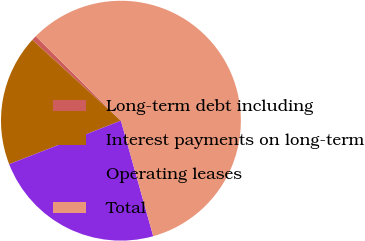Convert chart. <chart><loc_0><loc_0><loc_500><loc_500><pie_chart><fcel>Long-term debt including<fcel>Interest payments on long-term<fcel>Operating leases<fcel>Total<nl><fcel>0.67%<fcel>17.67%<fcel>23.43%<fcel>58.22%<nl></chart> 